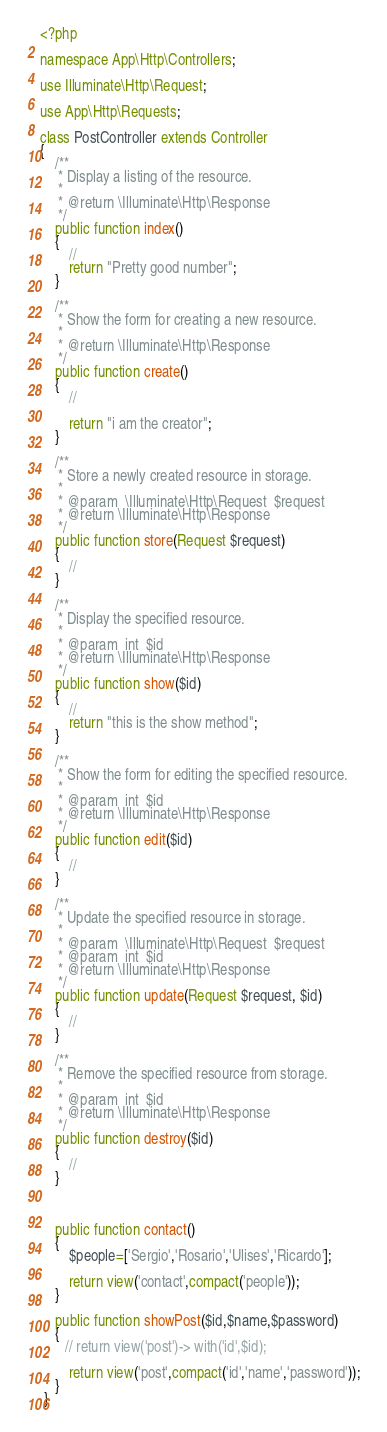<code> <loc_0><loc_0><loc_500><loc_500><_PHP_><?php

namespace App\Http\Controllers;

use Illuminate\Http\Request;

use App\Http\Requests;

class PostController extends Controller
{
    /**
     * Display a listing of the resource.
     *
     * @return \Illuminate\Http\Response
     */
    public function index()
    {
        //
        return "Pretty good number";
    }

    /**
     * Show the form for creating a new resource.
     *
     * @return \Illuminate\Http\Response
     */
    public function create()
    {
        //

        return "i am the creator";
    }

    /**
     * Store a newly created resource in storage.
     *
     * @param  \Illuminate\Http\Request  $request
     * @return \Illuminate\Http\Response
     */
    public function store(Request $request)
    {
        //
    }

    /**
     * Display the specified resource.
     *
     * @param  int  $id
     * @return \Illuminate\Http\Response
     */
    public function show($id)
    {
        //
        return "this is the show method";
    }

    /**
     * Show the form for editing the specified resource.
     *
     * @param  int  $id
     * @return \Illuminate\Http\Response
     */
    public function edit($id)
    {
        //
    }

    /**
     * Update the specified resource in storage.
     *
     * @param  \Illuminate\Http\Request  $request
     * @param  int  $id
     * @return \Illuminate\Http\Response
     */
    public function update(Request $request, $id)
    {
        //
    }

    /**
     * Remove the specified resource from storage.
     *
     * @param  int  $id
     * @return \Illuminate\Http\Response
     */
    public function destroy($id)
    {
        //
    }



    public function contact()
    {
        $people=['Sergio','Rosario','Ulises','Ricardo'];
        
        return view('contact',compact('people'));
    }

    public function showPost($id,$name,$password)
    {
       // return view('post')-> with('id',$id);

        return view('post',compact('id','name','password'));
    }
 }
</code> 